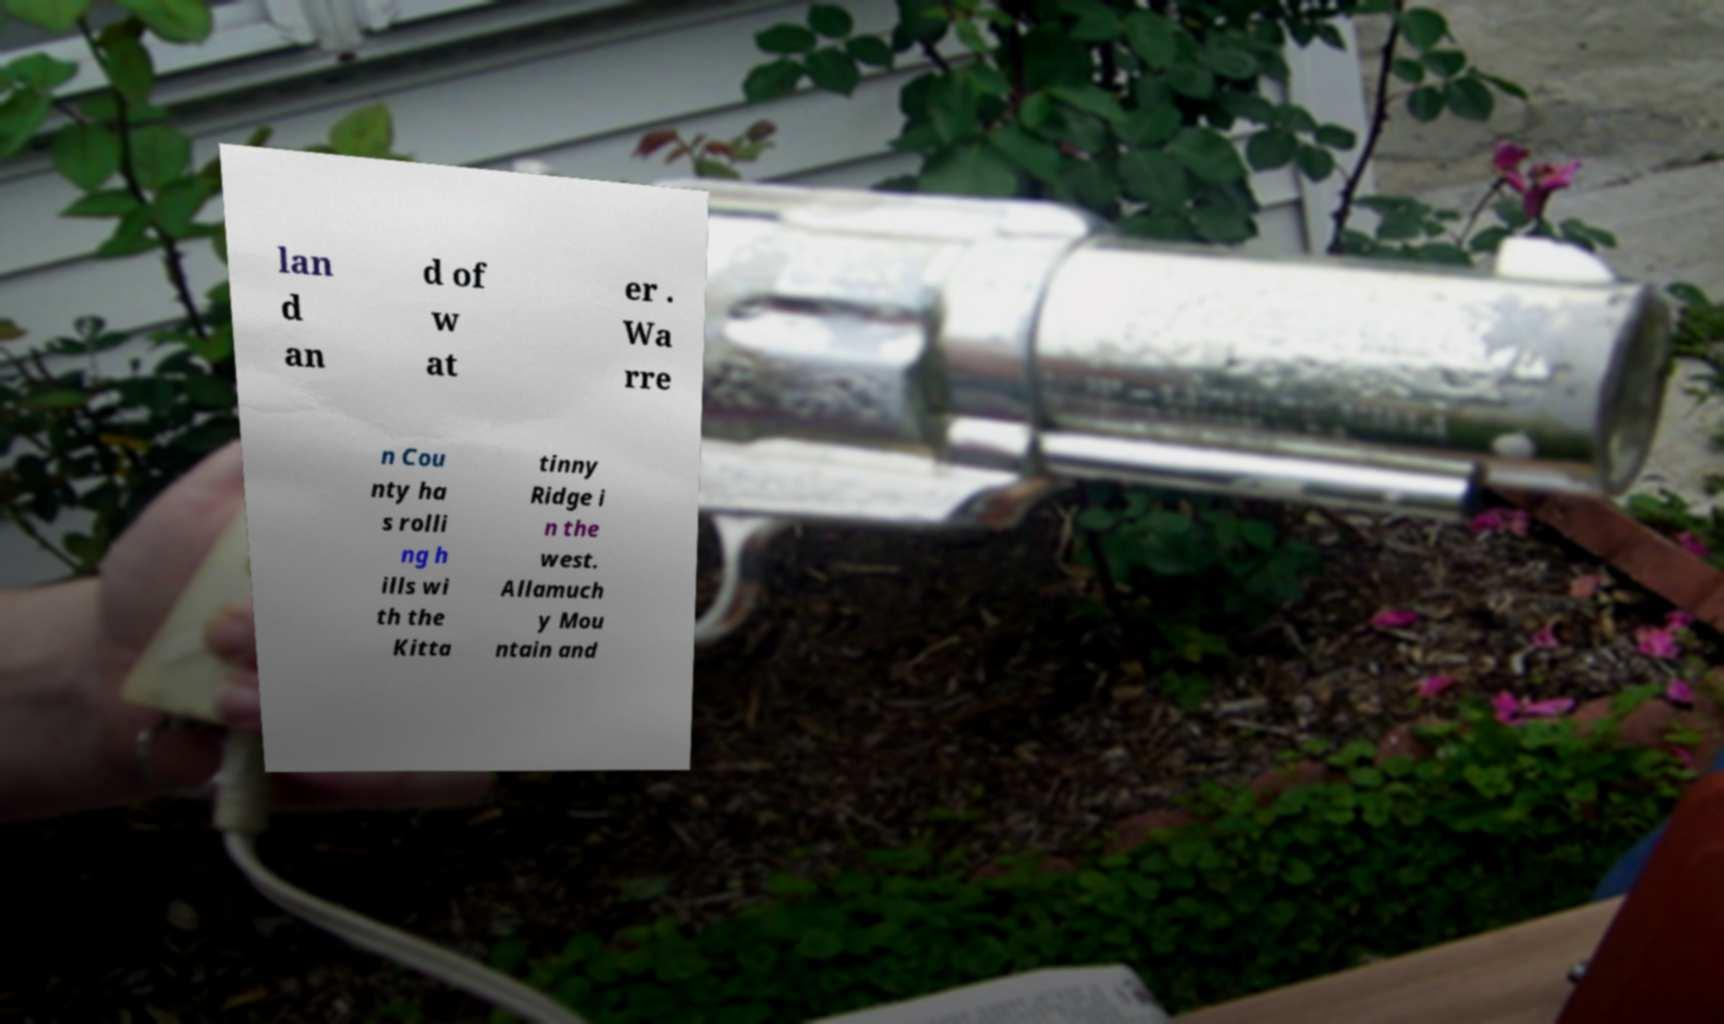For documentation purposes, I need the text within this image transcribed. Could you provide that? lan d an d of w at er . Wa rre n Cou nty ha s rolli ng h ills wi th the Kitta tinny Ridge i n the west. Allamuch y Mou ntain and 